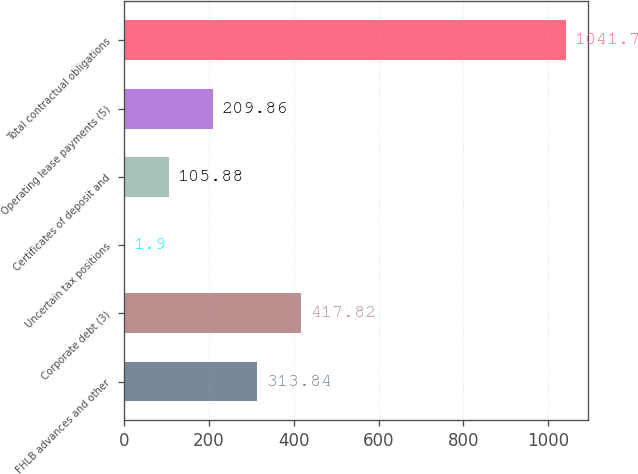Convert chart to OTSL. <chart><loc_0><loc_0><loc_500><loc_500><bar_chart><fcel>FHLB advances and other<fcel>Corporate debt (3)<fcel>Uncertain tax positions<fcel>Certificates of deposit and<fcel>Operating lease payments (5)<fcel>Total contractual obligations<nl><fcel>313.84<fcel>417.82<fcel>1.9<fcel>105.88<fcel>209.86<fcel>1041.7<nl></chart> 